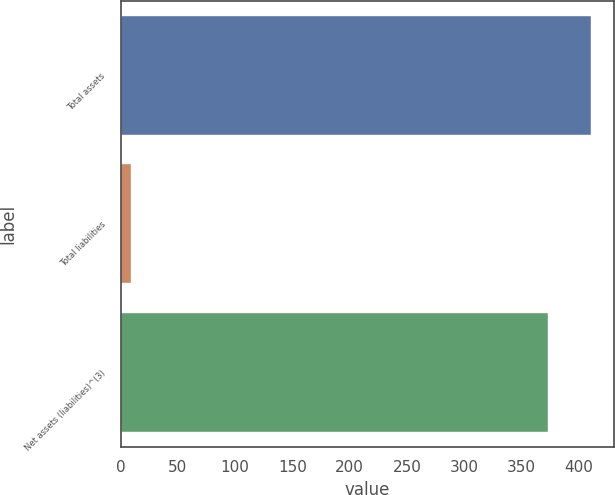Convert chart. <chart><loc_0><loc_0><loc_500><loc_500><bar_chart><fcel>Total assets<fcel>Total liabilities<fcel>Net assets (liabilities)^(3)<nl><fcel>410.3<fcel>9<fcel>373<nl></chart> 